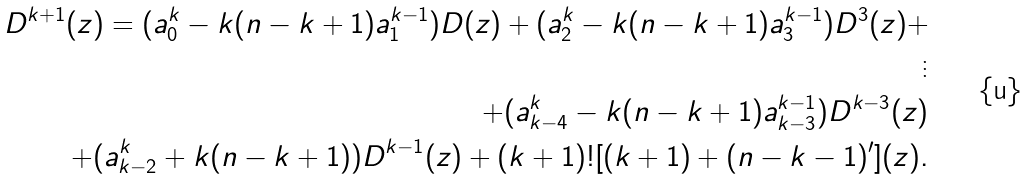<formula> <loc_0><loc_0><loc_500><loc_500>D ^ { k + 1 } ( z ) = ( a _ { 0 } ^ { k } - k ( n - k + 1 ) a _ { 1 } ^ { k - 1 } ) D ( z ) + ( a _ { 2 } ^ { k } - k ( n - k + 1 ) a _ { 3 } ^ { k - 1 } ) D ^ { 3 } ( z ) + \\ \vdots \\ + ( a _ { k - 4 } ^ { k } - k ( n - k + 1 ) a _ { k - 3 } ^ { k - 1 } ) D ^ { k - 3 } ( z ) \\ + ( a _ { k - 2 } ^ { k } + k ( n - k + 1 ) ) D ^ { k - 1 } ( z ) + ( k + 1 ) ! [ ( k + 1 ) + ( n - k - 1 ) ^ { \prime } ] ( z ) .</formula> 